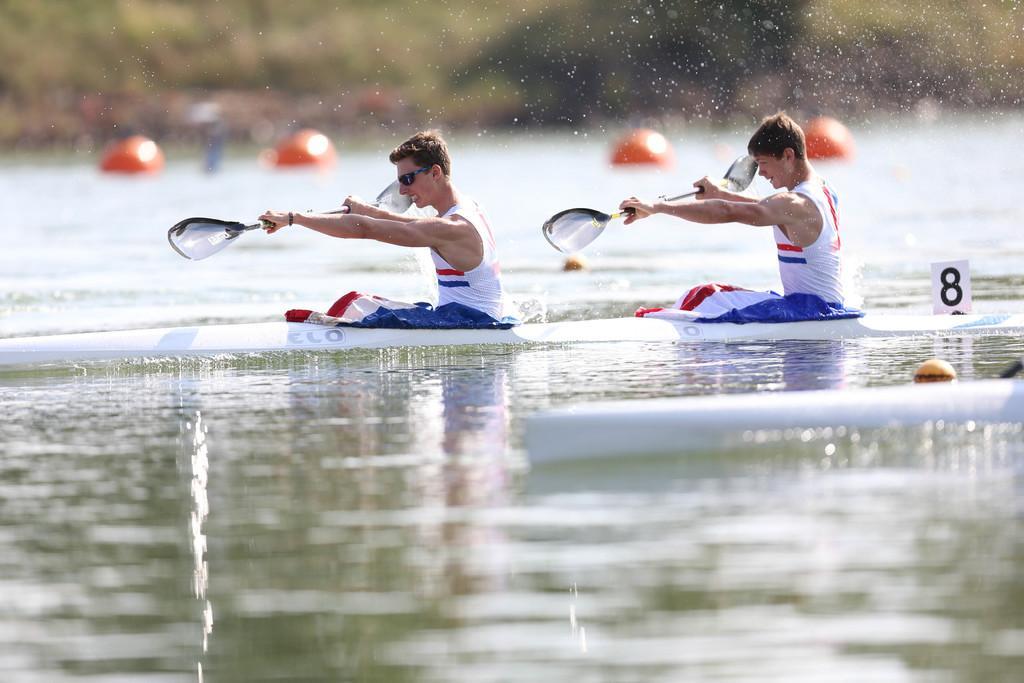Describe this image in one or two sentences. In the center of the image we can see two people are doing row boats. In the background of the image we can see the water. On the right side of the image we can see a sign board. At the top, the image is blurred. 